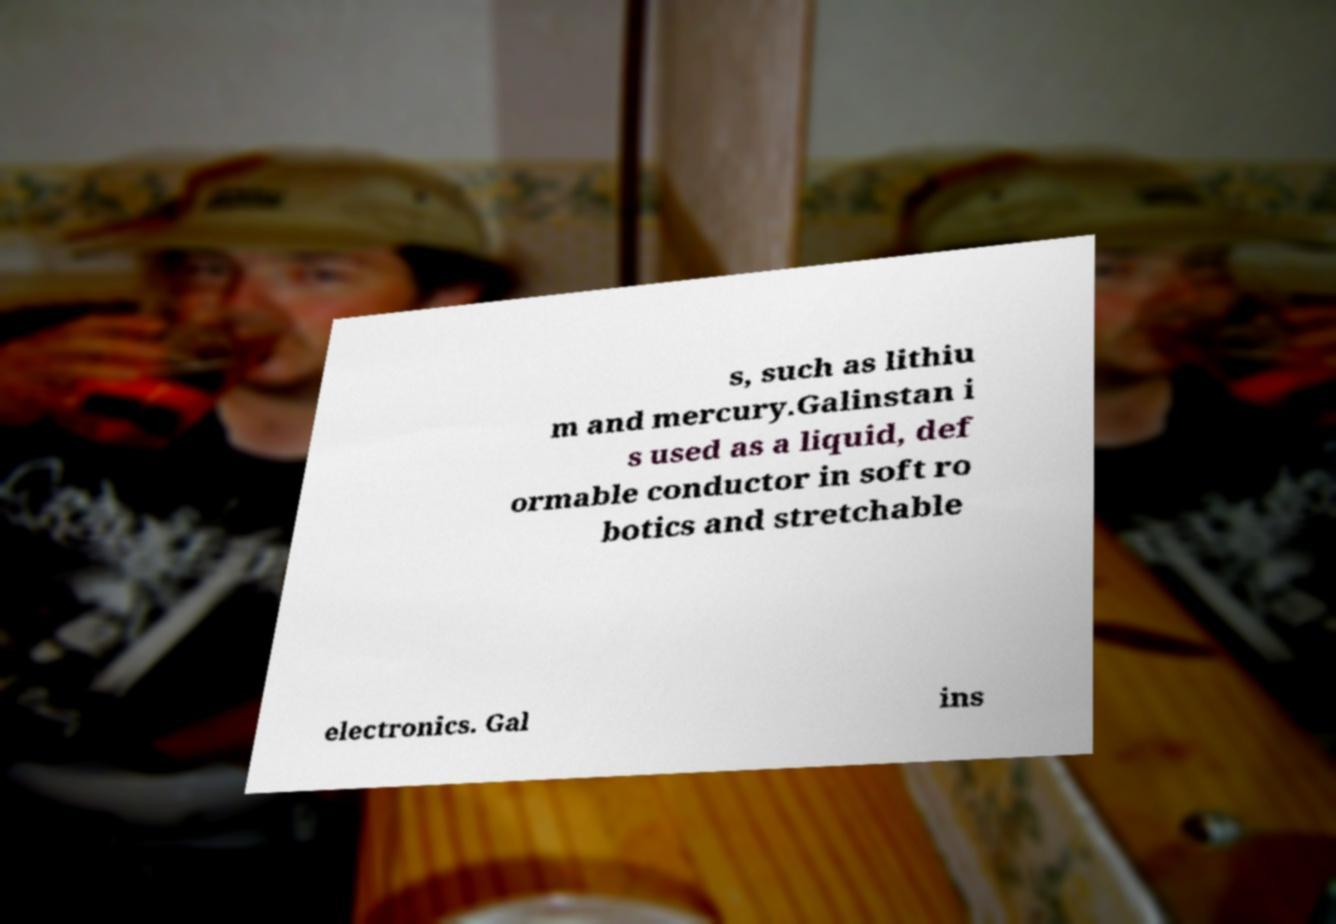Can you read and provide the text displayed in the image?This photo seems to have some interesting text. Can you extract and type it out for me? s, such as lithiu m and mercury.Galinstan i s used as a liquid, def ormable conductor in soft ro botics and stretchable electronics. Gal ins 